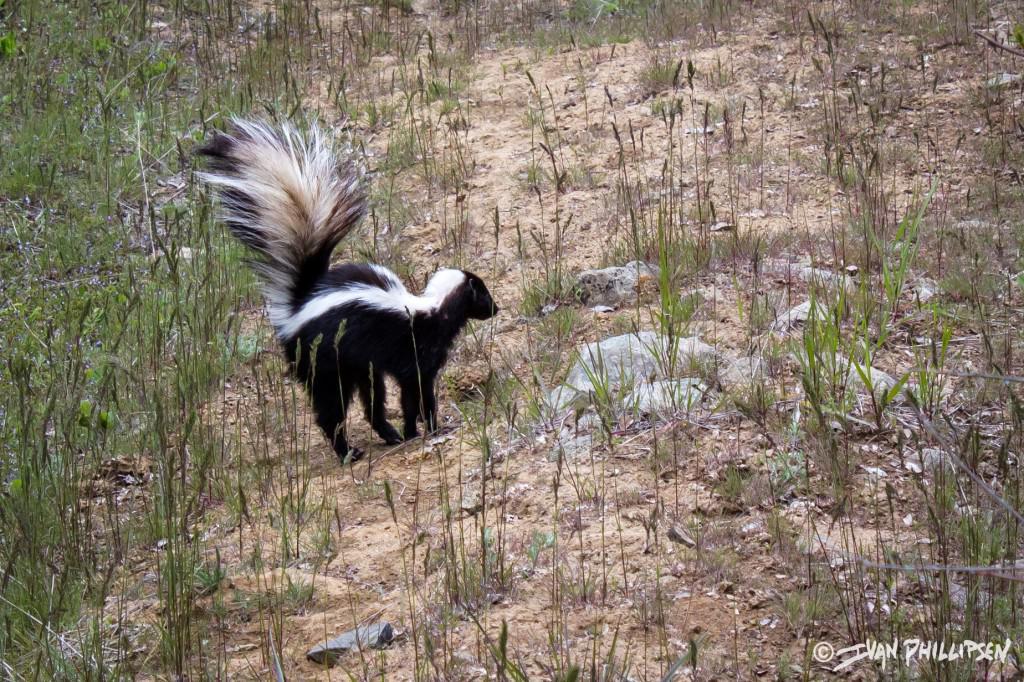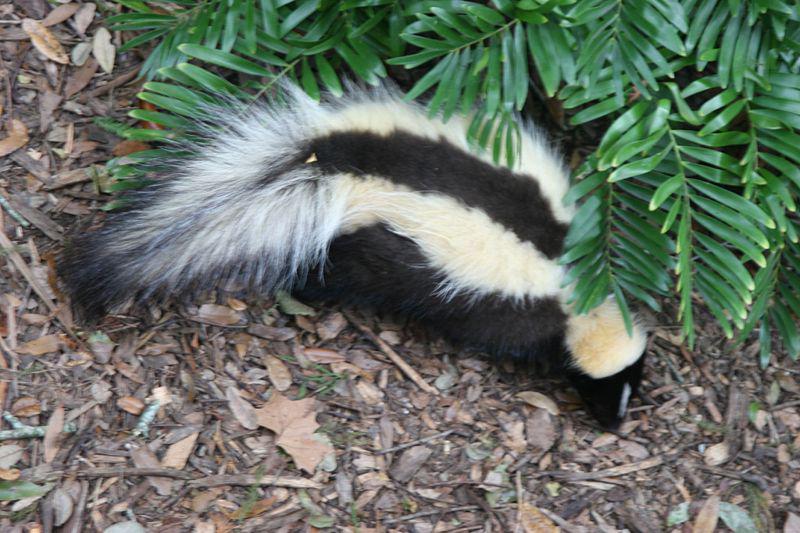The first image is the image on the left, the second image is the image on the right. Evaluate the accuracy of this statement regarding the images: "Each image contains exactly one skunk, which is on all fours with its body turned rightward.". Is it true? Answer yes or no. Yes. The first image is the image on the left, the second image is the image on the right. For the images shown, is this caption "There are two skunks that are positioned in a similar direction." true? Answer yes or no. Yes. 